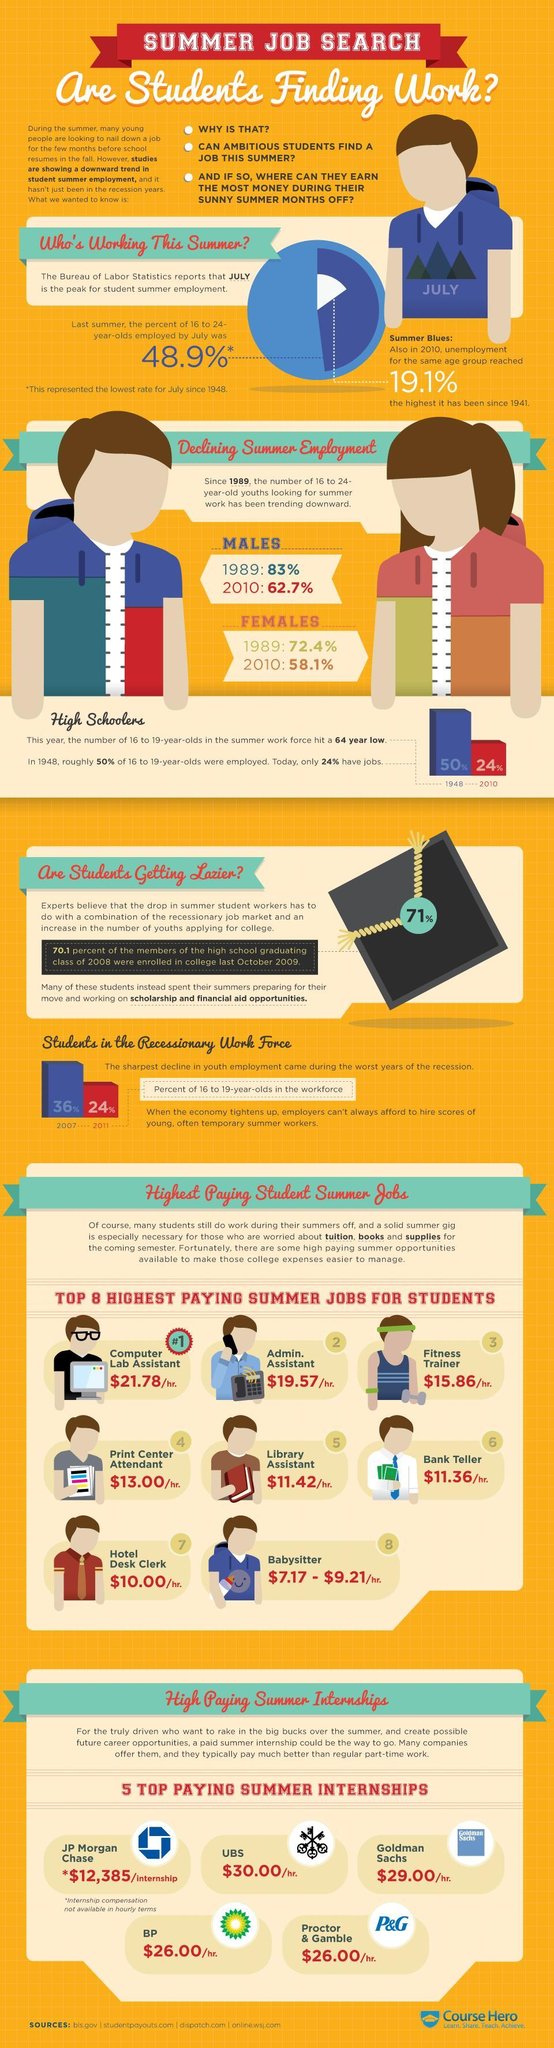What is the hourly salary paid for a Bank teller?
Answer the question with a short phrase. $11.36/hr. Which is the highest paid job for students? Computer Lab Assistant What percentage of 16 to 19 years old youth were employed in 2010? 24% What is the payment offered by UBS company for summer internship of students? $30.00/hr. Which is the least paid job for students? Babysitter Which is the second highest paid job for students? Admin. Assistant What percentage of females in the age group of 16-24 were looking for summer work in 1989? 72.4% What percentage of males in the age group of 16-24 were looking for summer work in 2010? 62.7% What is the hourly salary paid for a fitness trainer? $15.86/hr. Which company offers the highest payment for summer internships of students? JP Morgan Chase 